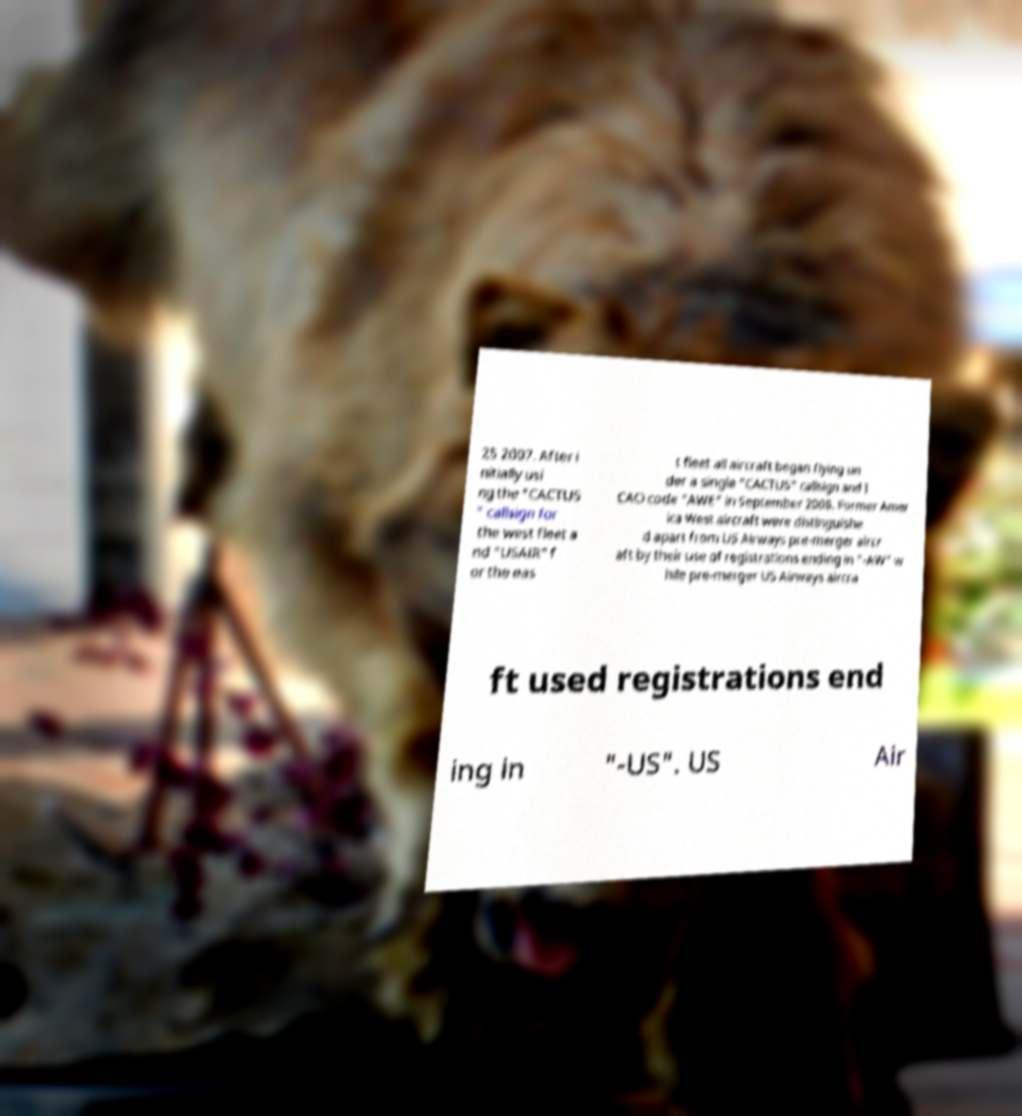Could you assist in decoding the text presented in this image and type it out clearly? 25 2007. After i nitially usi ng the "CACTUS " callsign for the west fleet a nd "USAIR" f or the eas t fleet all aircraft began flying un der a single "CACTUS" callsign and I CAO code "AWE" in September 2008. Former Amer ica West aircraft were distinguishe d apart from US Airways pre-merger aircr aft by their use of registrations ending in "-AW" w hile pre-merger US Airways aircra ft used registrations end ing in "-US". US Air 